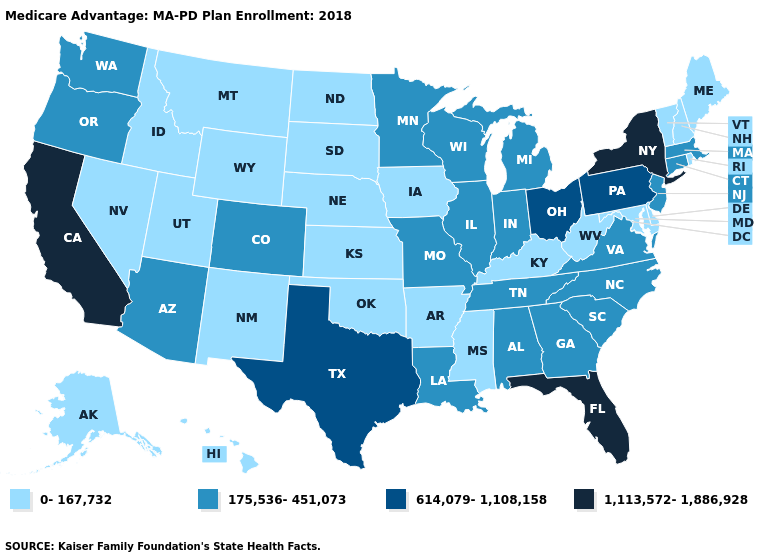What is the highest value in the USA?
Short answer required. 1,113,572-1,886,928. Does Massachusetts have the highest value in the USA?
Keep it brief. No. Among the states that border Massachusetts , which have the lowest value?
Short answer required. New Hampshire, Rhode Island, Vermont. Name the states that have a value in the range 1,113,572-1,886,928?
Concise answer only. California, Florida, New York. Does Wisconsin have the lowest value in the MidWest?
Quick response, please. No. Does Florida have a higher value than California?
Write a very short answer. No. Which states hav the highest value in the South?
Keep it brief. Florida. Which states hav the highest value in the Northeast?
Short answer required. New York. What is the highest value in states that border Idaho?
Quick response, please. 175,536-451,073. What is the lowest value in the USA?
Write a very short answer. 0-167,732. What is the value of Wyoming?
Short answer required. 0-167,732. What is the value of Maine?
Be succinct. 0-167,732. What is the value of West Virginia?
Short answer required. 0-167,732. What is the value of New Jersey?
Give a very brief answer. 175,536-451,073. 